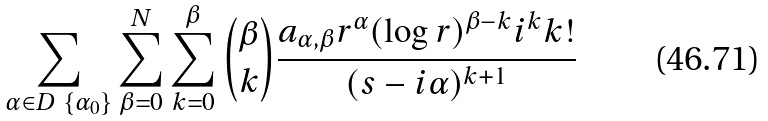Convert formula to latex. <formula><loc_0><loc_0><loc_500><loc_500>\sum _ { \alpha \in D \ \{ \alpha _ { 0 } \} } \sum _ { \beta = 0 } ^ { N } \sum _ { k = 0 } ^ { \beta } { \beta \choose k } \frac { a _ { \alpha , \beta } r ^ { \alpha } ( \log r ) ^ { \beta - k } i ^ { k } k ! } { ( s - i \alpha ) ^ { k + 1 } }</formula> 